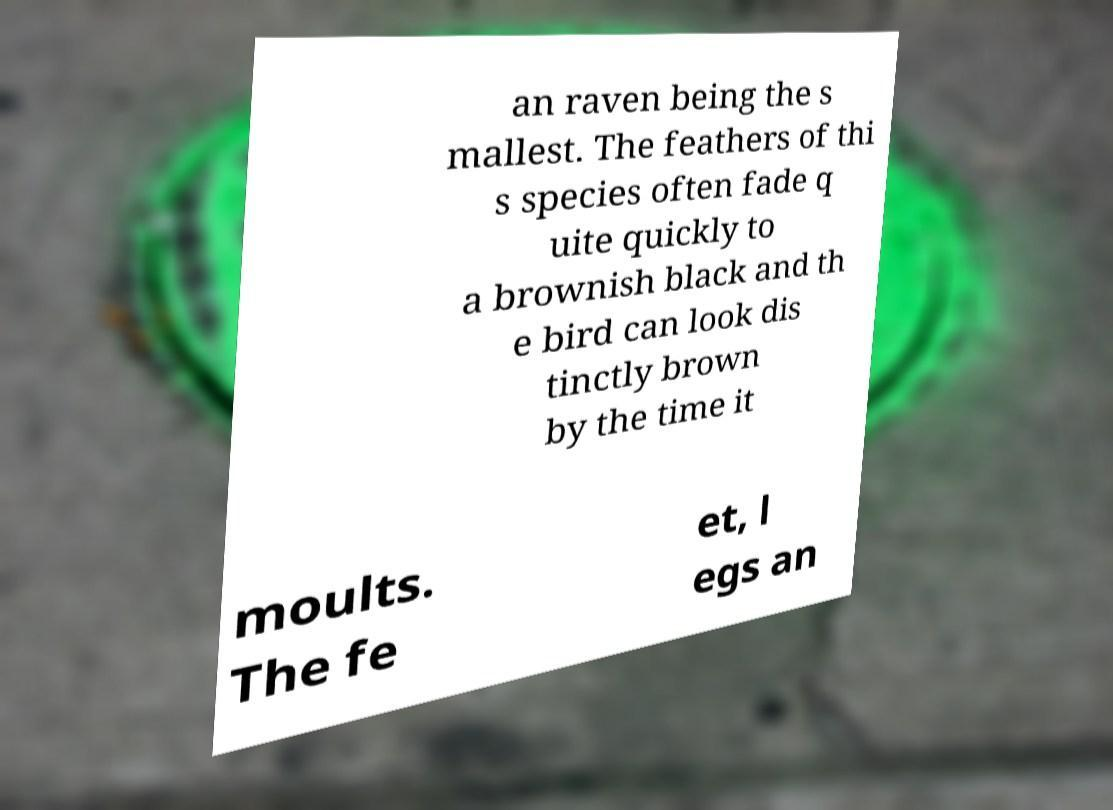I need the written content from this picture converted into text. Can you do that? an raven being the s mallest. The feathers of thi s species often fade q uite quickly to a brownish black and th e bird can look dis tinctly brown by the time it moults. The fe et, l egs an 